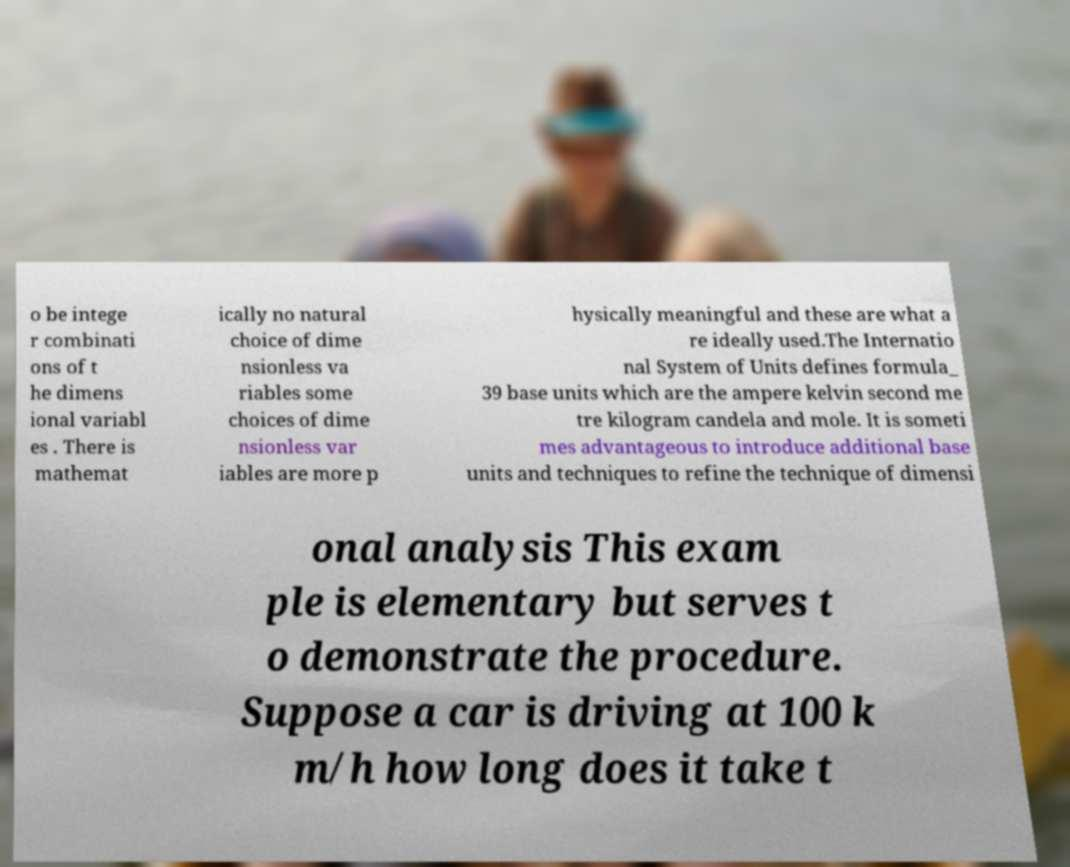I need the written content from this picture converted into text. Can you do that? o be intege r combinati ons of t he dimens ional variabl es . There is mathemat ically no natural choice of dime nsionless va riables some choices of dime nsionless var iables are more p hysically meaningful and these are what a re ideally used.The Internatio nal System of Units defines formula_ 39 base units which are the ampere kelvin second me tre kilogram candela and mole. It is someti mes advantageous to introduce additional base units and techniques to refine the technique of dimensi onal analysis This exam ple is elementary but serves t o demonstrate the procedure. Suppose a car is driving at 100 k m/h how long does it take t 